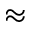Convert formula to latex. <formula><loc_0><loc_0><loc_500><loc_500>\approx</formula> 